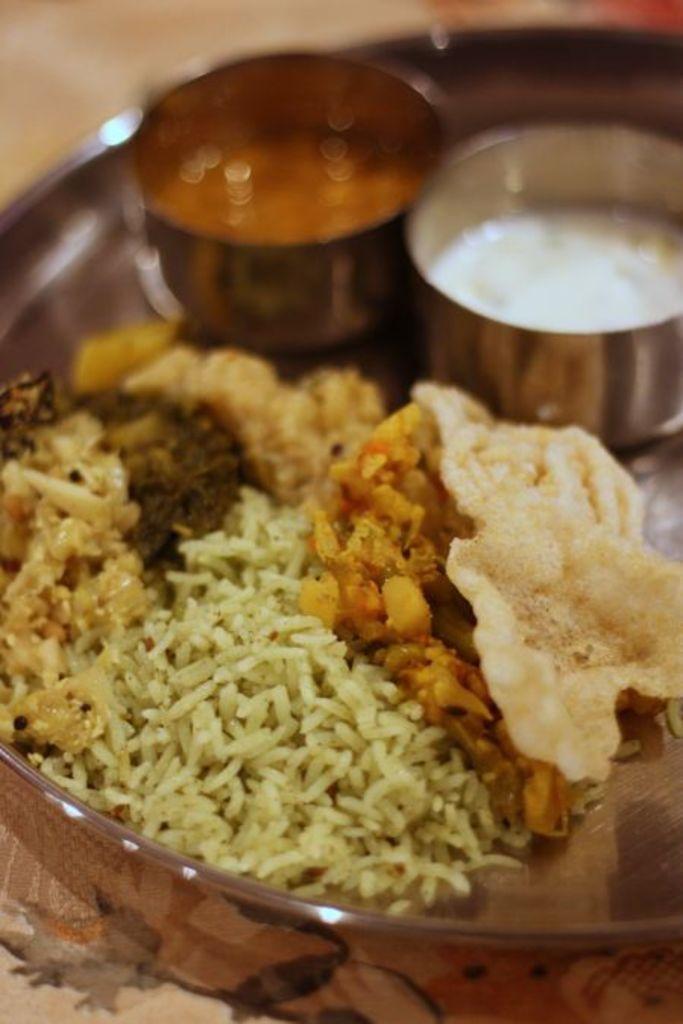Can you describe this image briefly? In this image I see a silver color plate on which there is rice and different food items and I see 2 bowls over here in which there is red and white color food and I see that it is blurred in the background. 